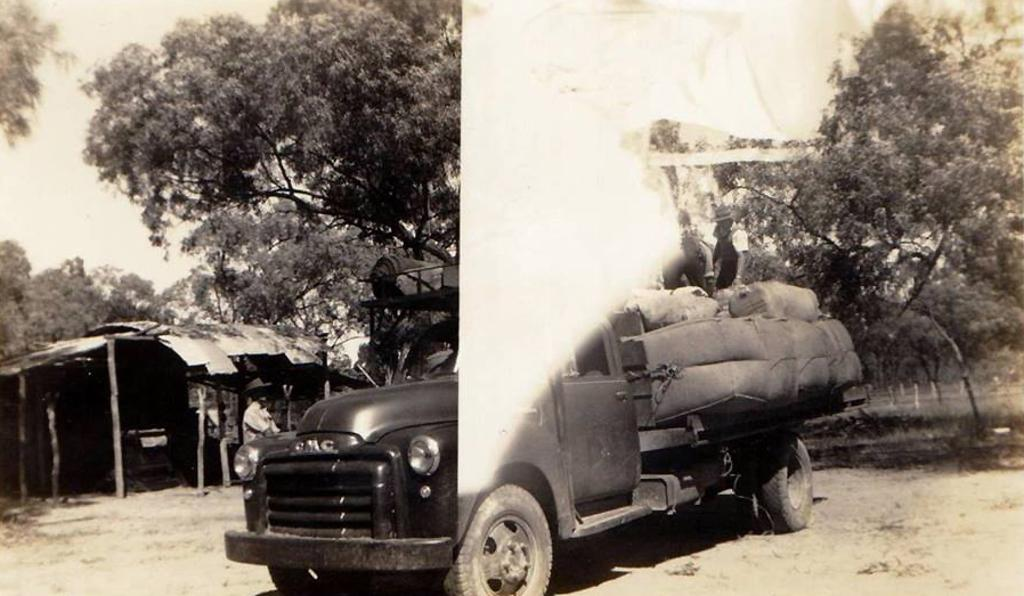What is the color scheme of the image? The image is black and white. What can be seen in the image besides the color scheme? There is a vehicle, trees, a white shade, and a shed in the image. What type of zinc is present in the image? There is no zinc present in the image. How does the anger in the image manifest itself? There is no anger present in the image; it is a black and white image featuring a vehicle, trees, a white shade, and a shed. 